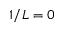<formula> <loc_0><loc_0><loc_500><loc_500>1 / L = 0</formula> 